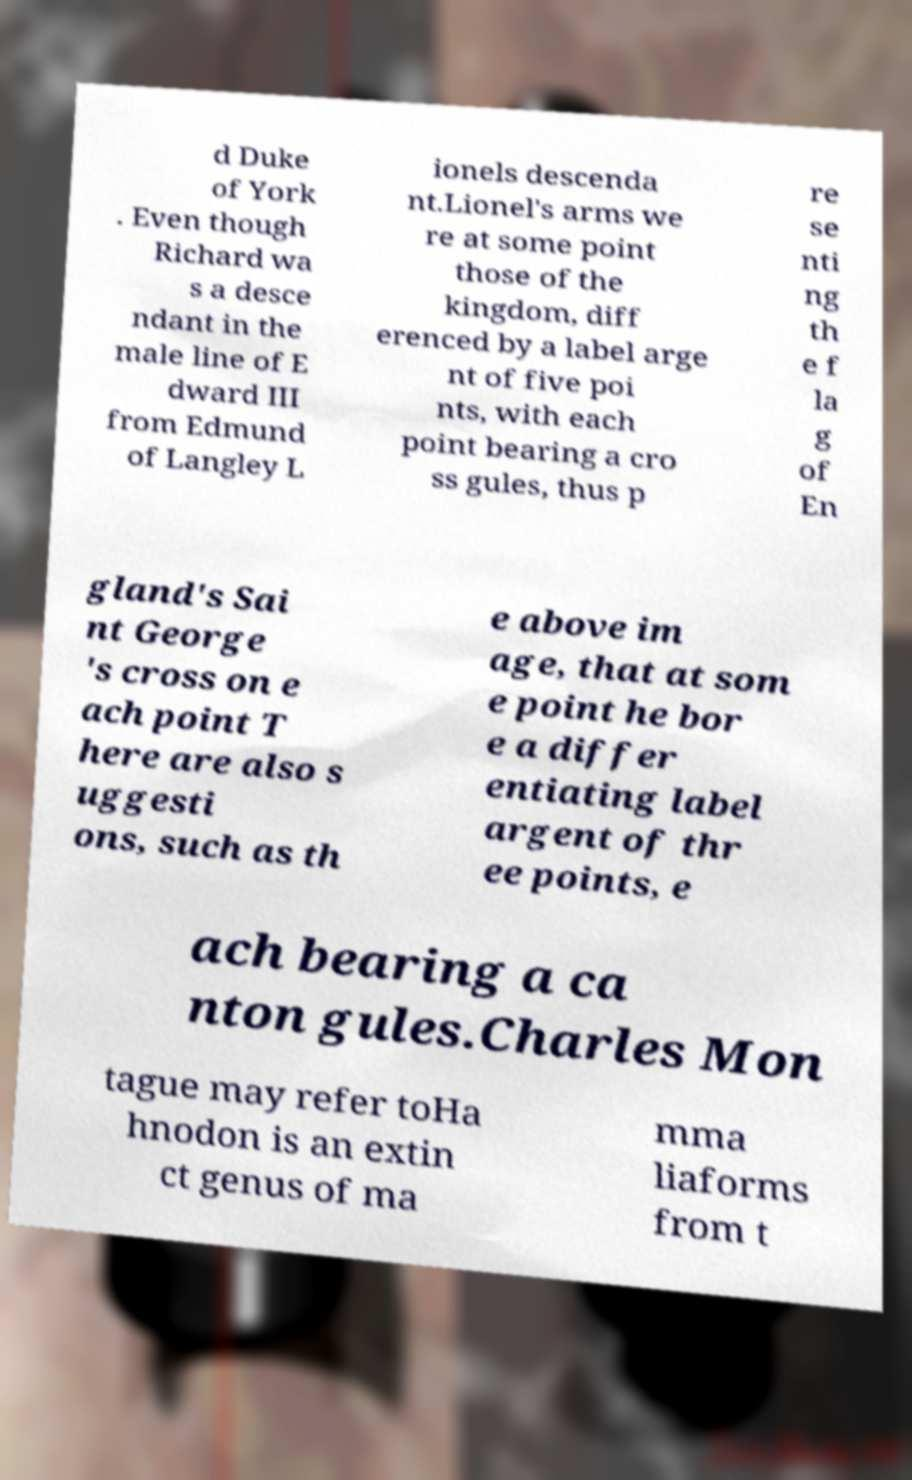For documentation purposes, I need the text within this image transcribed. Could you provide that? d Duke of York . Even though Richard wa s a desce ndant in the male line of E dward III from Edmund of Langley L ionels descenda nt.Lionel's arms we re at some point those of the kingdom, diff erenced by a label arge nt of five poi nts, with each point bearing a cro ss gules, thus p re se nti ng th e f la g of En gland's Sai nt George 's cross on e ach point T here are also s uggesti ons, such as th e above im age, that at som e point he bor e a differ entiating label argent of thr ee points, e ach bearing a ca nton gules.Charles Mon tague may refer toHa hnodon is an extin ct genus of ma mma liaforms from t 